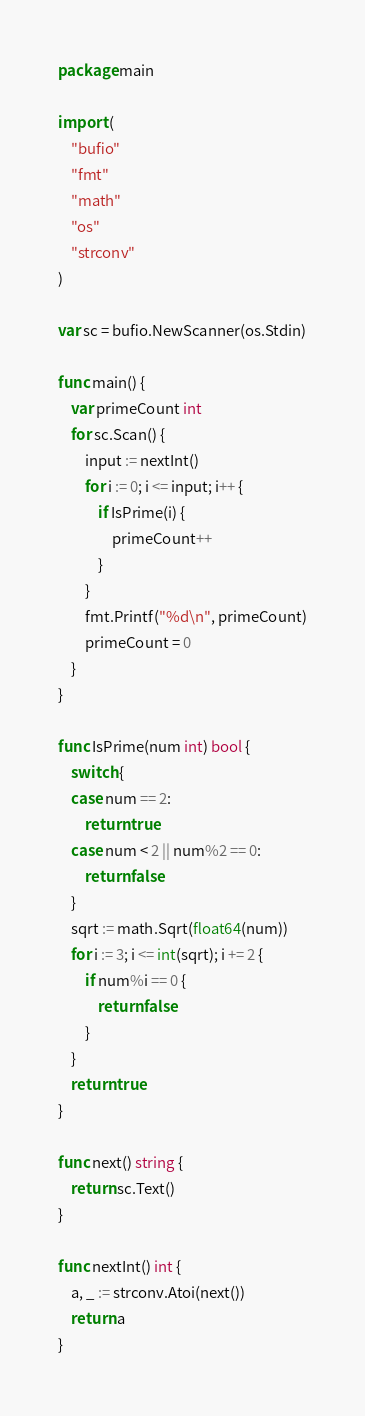Convert code to text. <code><loc_0><loc_0><loc_500><loc_500><_Go_>package main

import (
	"bufio"
	"fmt"
	"math"
	"os"
	"strconv"
)

var sc = bufio.NewScanner(os.Stdin)

func main() {
	var primeCount int
	for sc.Scan() {
		input := nextInt()
		for i := 0; i <= input; i++ {
			if IsPrime(i) {
				primeCount++
			}
		}
		fmt.Printf("%d\n", primeCount)
		primeCount = 0
	}
}

func IsPrime(num int) bool {
	switch {
	case num == 2:
		return true
	case num < 2 || num%2 == 0:
		return false
	}
	sqrt := math.Sqrt(float64(num))
	for i := 3; i <= int(sqrt); i += 2 {
		if num%i == 0 {
			return false
		}
	}
	return true
}

func next() string {
	return sc.Text()
}

func nextInt() int {
	a, _ := strconv.Atoi(next())
	return a
}

</code> 